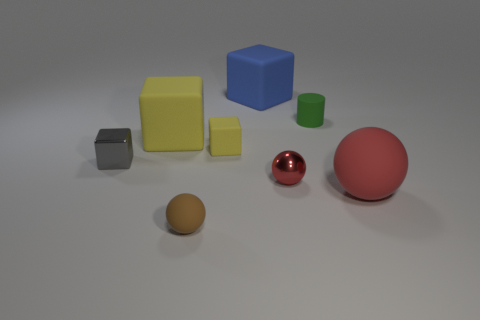The small object that is the same color as the big matte sphere is what shape?
Offer a very short reply. Sphere. There is a brown ball that is made of the same material as the green object; what size is it?
Offer a terse response. Small. Do the green cylinder and the shiny object that is right of the small gray cube have the same size?
Your answer should be very brief. Yes. The rubber thing that is both to the right of the small yellow thing and left of the rubber cylinder is what color?
Keep it short and to the point. Blue. How many objects are either big rubber things that are right of the small gray shiny cube or small things that are to the left of the cylinder?
Ensure brevity in your answer.  7. What color is the big rubber cube behind the large block to the left of the tiny matte thing that is in front of the tiny gray shiny cube?
Offer a very short reply. Blue. Are there any big red matte objects of the same shape as the large yellow thing?
Give a very brief answer. No. How many red matte things are there?
Ensure brevity in your answer.  1. What shape is the green rubber object?
Keep it short and to the point. Cylinder. How many shiny things have the same size as the red matte ball?
Provide a succinct answer. 0. 